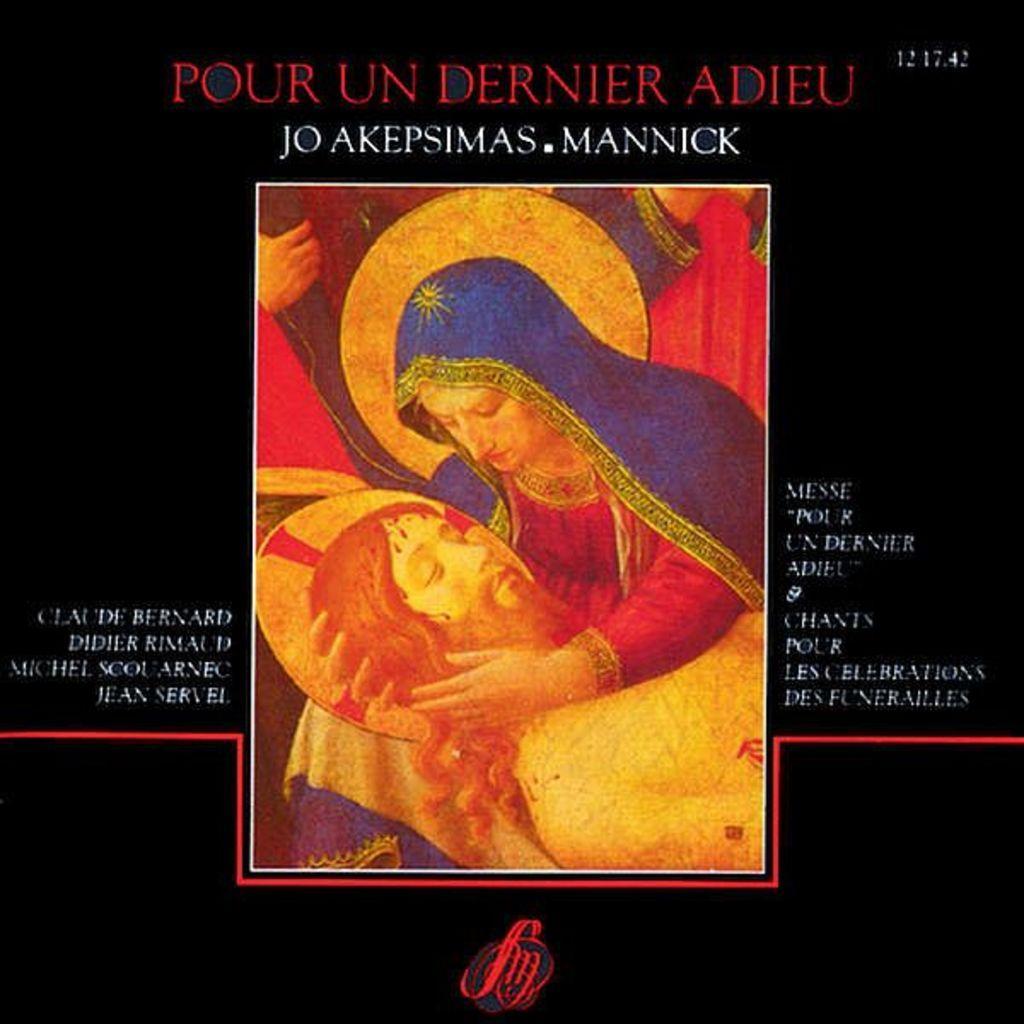In one or two sentences, can you explain what this image depicts? In this image there is a poster. In the center of the image there is a picture. There is a woman holding the head of a man. Around the picture there is text. At the bottom there is a logo on the poster. 